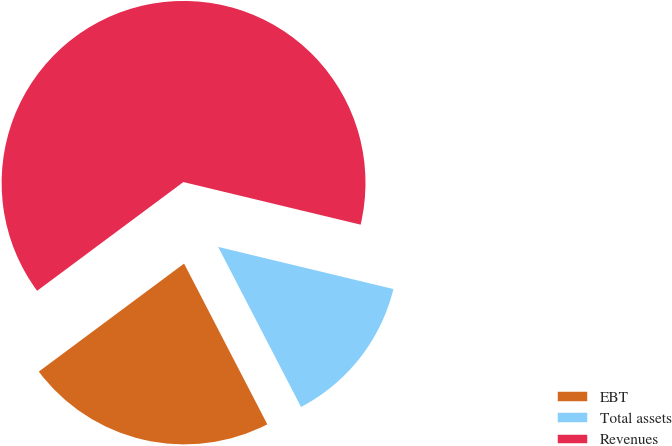Convert chart. <chart><loc_0><loc_0><loc_500><loc_500><pie_chart><fcel>EBT<fcel>Total assets<fcel>Revenues<nl><fcel>22.43%<fcel>13.64%<fcel>63.93%<nl></chart> 